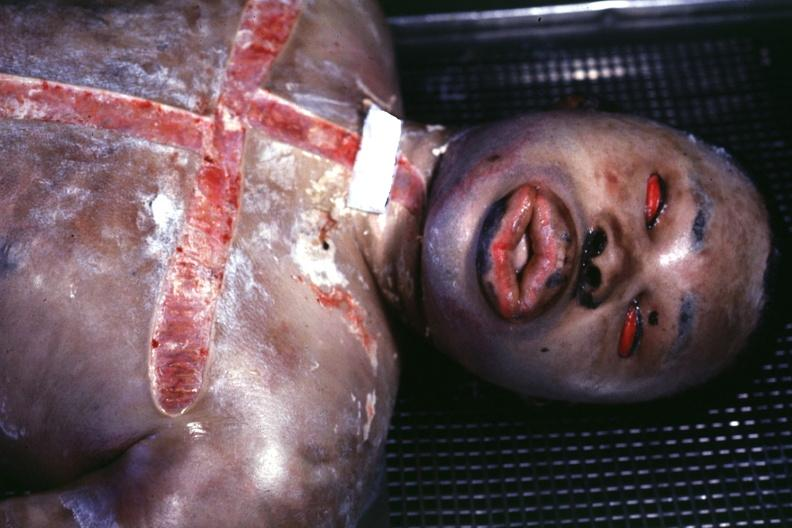what is view of face showing?
Answer the question using a single word or phrase. Grotesque edema 